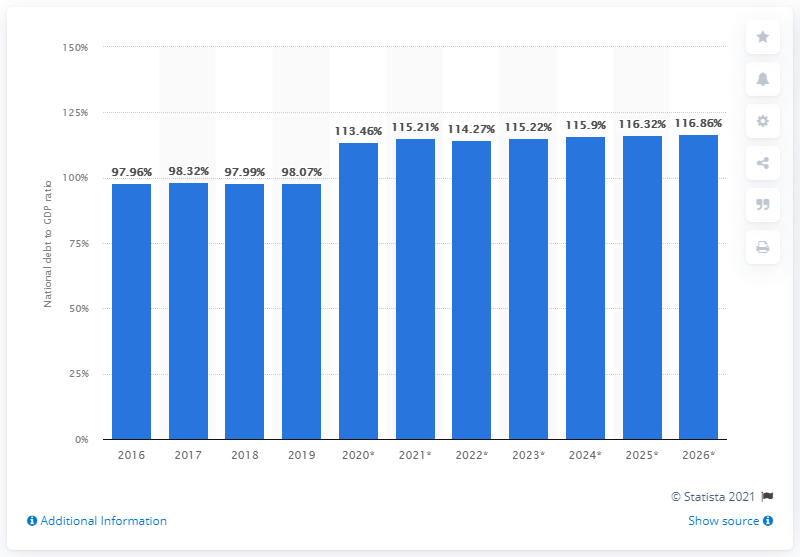Draw attention to some important aspects in this diagram. France's national debt accounted for approximately 98.07% of the country's gross domestic product in 2019. 